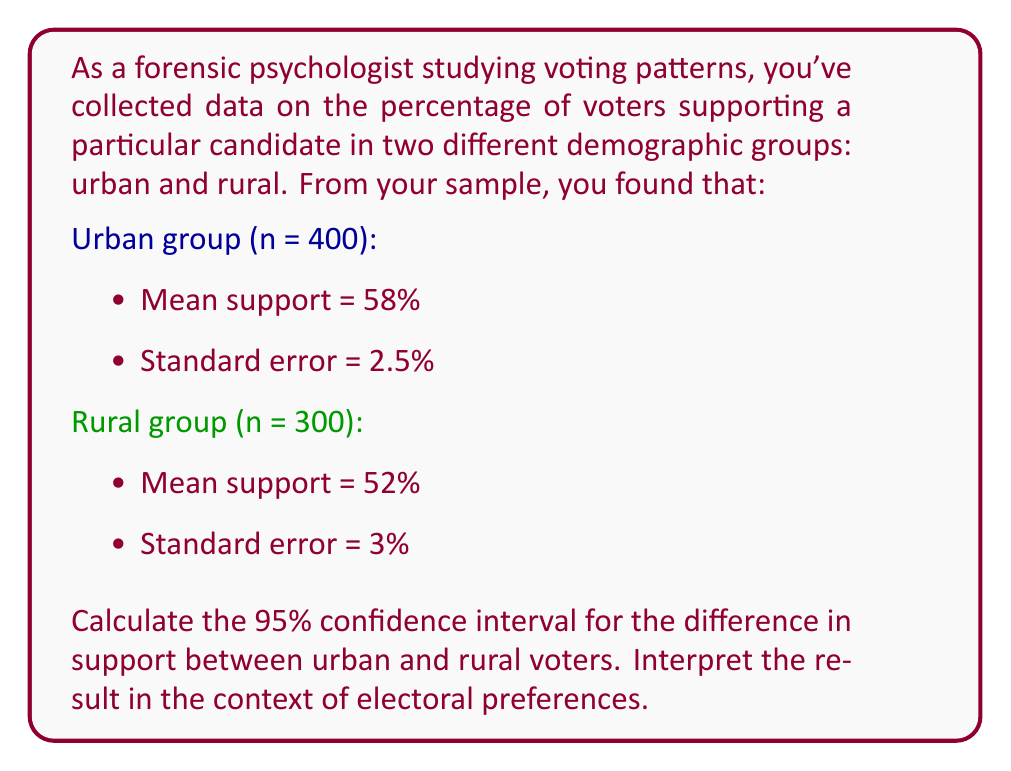Help me with this question. To solve this problem, we'll follow these steps:

1) The formula for the confidence interval of the difference between two means is:

   $$(x̄_1 - x̄_2) ± z_{\alpha/2} \sqrt{SE_1^2 + SE_2^2}$$

   Where $x̄_1$ and $x̄_2$ are the sample means, $SE_1$ and $SE_2$ are the standard errors, and $z_{\alpha/2}$ is the z-score for the desired confidence level.

2) We have:
   $x̄_1$ (urban) = 58%
   $x̄_2$ (rural) = 52%
   $SE_1$ = 2.5%
   $SE_2$ = 3%
   For a 95% confidence interval, $z_{\alpha/2}$ = 1.96

3) Let's calculate the difference in means:
   $x̄_1 - x̄_2 = 58% - 52% = 6%$

4) Now, let's calculate $\sqrt{SE_1^2 + SE_2^2}$:
   $\sqrt{(2.5%)^2 + (3%)^2} = \sqrt{0.0625% + 0.09%} = \sqrt{0.1525%} \approx 3.91%$

5) Multiply this by 1.96:
   $1.96 * 3.91% \approx 7.66%$

6) Now we can construct the confidence interval:
   $6% ± 7.66%$
   
   Lower bound: $6% - 7.66% = -1.66%$
   Upper bound: $6% + 7.66% = 13.66%$

7) Therefore, the 95% confidence interval is (-1.66%, 13.66%)

Interpretation: We can be 95% confident that the true difference in support for the candidate between urban and rural voters falls between -1.66% and 13.66%. Since this interval includes 0, we cannot conclude that there is a statistically significant difference in support between urban and rural voters at the 5% significance level.
Answer: 95% CI: (-1.66%, 13.66%). No significant difference in support between urban and rural voters at α=0.05. 